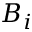Convert formula to latex. <formula><loc_0><loc_0><loc_500><loc_500>B _ { i }</formula> 